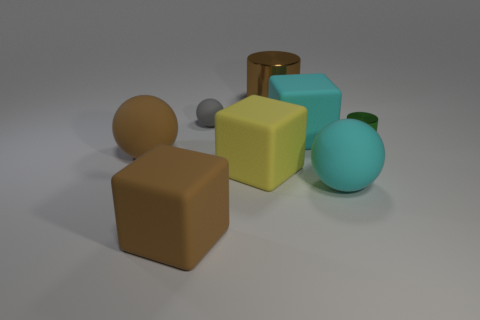Subtract all gray balls. How many balls are left? 2 Add 1 tiny rubber objects. How many objects exist? 9 Subtract all brown cubes. How many cubes are left? 2 Subtract all cylinders. How many objects are left? 6 Subtract 1 cubes. How many cubes are left? 2 Add 7 brown matte balls. How many brown matte balls exist? 8 Subtract 0 blue blocks. How many objects are left? 8 Subtract all brown cubes. Subtract all purple balls. How many cubes are left? 2 Subtract all big cyan cubes. Subtract all tiny gray matte spheres. How many objects are left? 6 Add 4 small green shiny objects. How many small green shiny objects are left? 5 